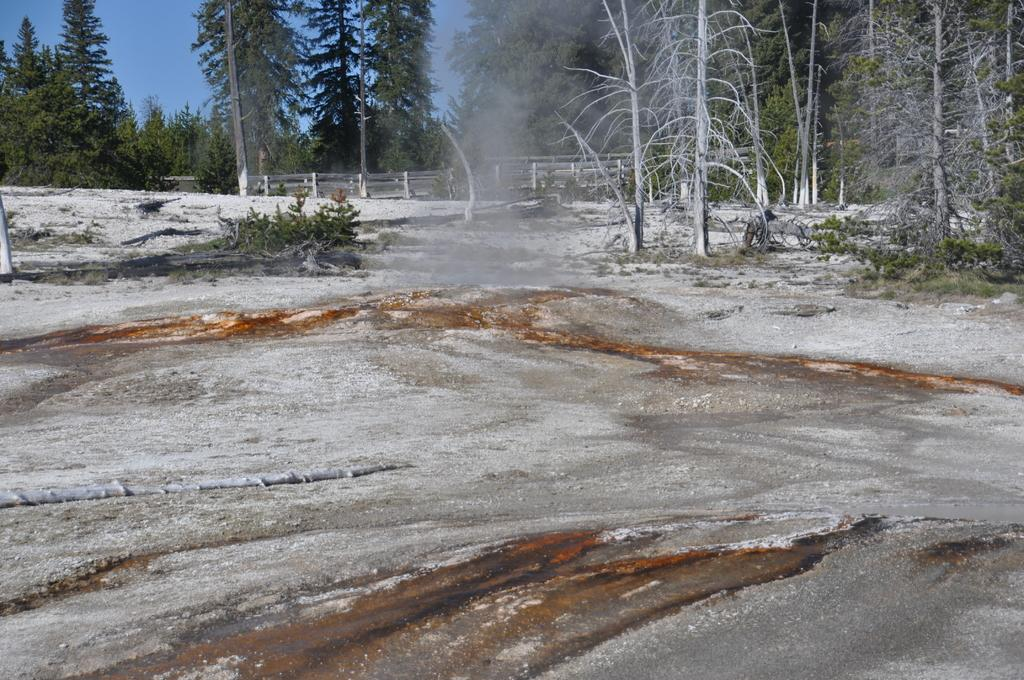What is located in the center of the image? There are trees in the center of the image. What type of structure can be seen in the image? There is a fence in the image. What is at the bottom of the image? There is a road at the bottom of the image. What can be seen in the background of the image? The sky is visible in the background of the image. What type of song is being sung by the trees in the image? There are no trees singing in the image; they are stationary and not making any sounds. Is there a coat hanging on the fence in the image? There is no coat present in the image; only trees, a fence, a road, and the sky are visible. 